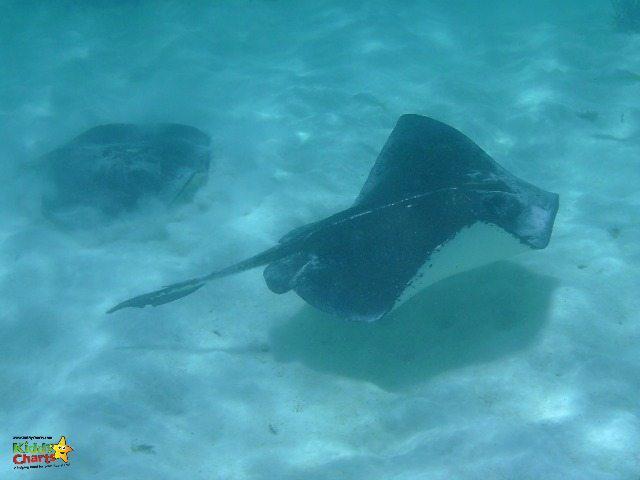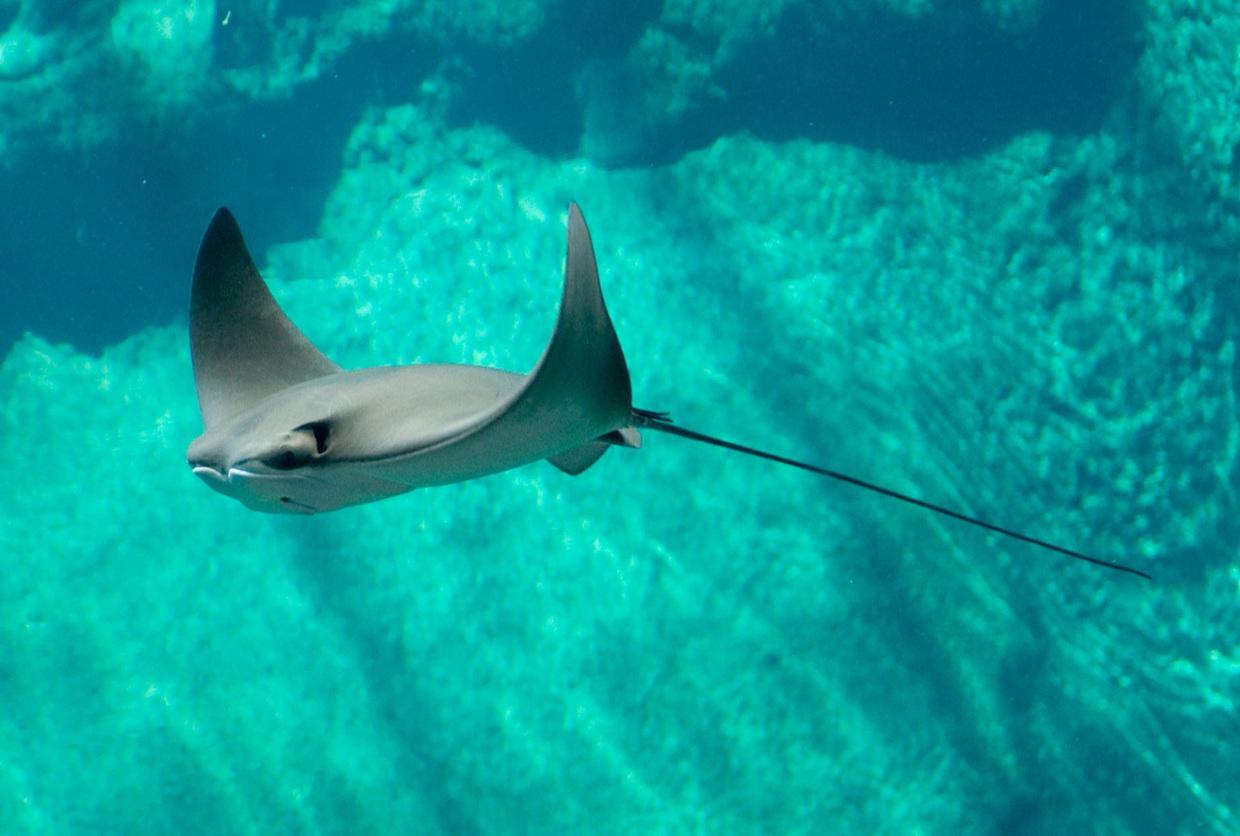The first image is the image on the left, the second image is the image on the right. For the images shown, is this caption "The left image contains a sting ray that is swimming slightly upwards towards the right." true? Answer yes or no. Yes. The first image is the image on the left, the second image is the image on the right. Assess this claim about the two images: "Each image contains a single stingray, and the stingrays in the right and left images face opposite direction.". Correct or not? Answer yes or no. No. 